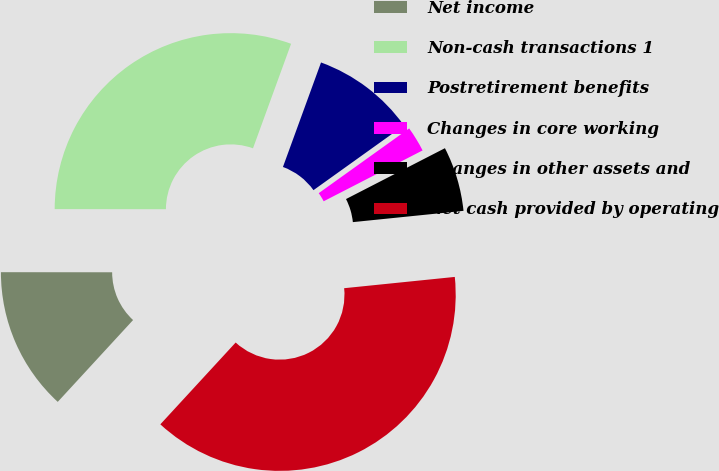Convert chart. <chart><loc_0><loc_0><loc_500><loc_500><pie_chart><fcel>Net income<fcel>Non-cash transactions 1<fcel>Postretirement benefits<fcel>Changes in core working<fcel>Changes in other assets and<fcel>Net cash provided by operating<nl><fcel>13.17%<fcel>30.55%<fcel>9.55%<fcel>2.33%<fcel>5.94%<fcel>38.46%<nl></chart> 